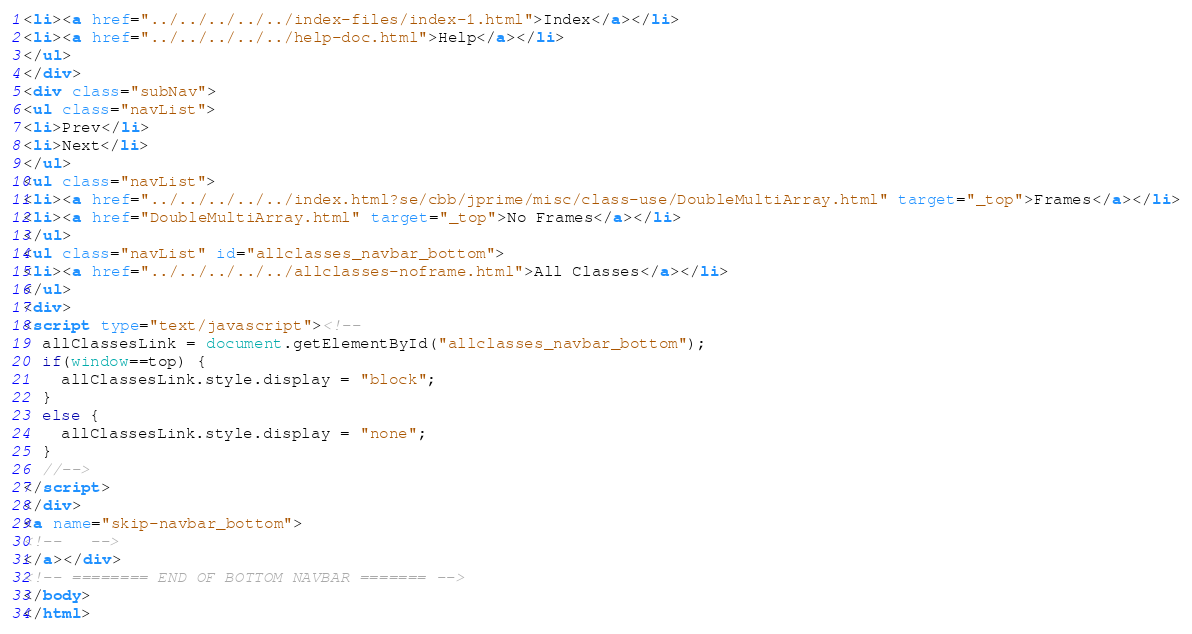<code> <loc_0><loc_0><loc_500><loc_500><_HTML_><li><a href="../../../../../index-files/index-1.html">Index</a></li>
<li><a href="../../../../../help-doc.html">Help</a></li>
</ul>
</div>
<div class="subNav">
<ul class="navList">
<li>Prev</li>
<li>Next</li>
</ul>
<ul class="navList">
<li><a href="../../../../../index.html?se/cbb/jprime/misc/class-use/DoubleMultiArray.html" target="_top">Frames</a></li>
<li><a href="DoubleMultiArray.html" target="_top">No Frames</a></li>
</ul>
<ul class="navList" id="allclasses_navbar_bottom">
<li><a href="../../../../../allclasses-noframe.html">All Classes</a></li>
</ul>
<div>
<script type="text/javascript"><!--
  allClassesLink = document.getElementById("allclasses_navbar_bottom");
  if(window==top) {
    allClassesLink.style.display = "block";
  }
  else {
    allClassesLink.style.display = "none";
  }
  //-->
</script>
</div>
<a name="skip-navbar_bottom">
<!--   -->
</a></div>
<!-- ======== END OF BOTTOM NAVBAR ======= -->
</body>
</html>
</code> 